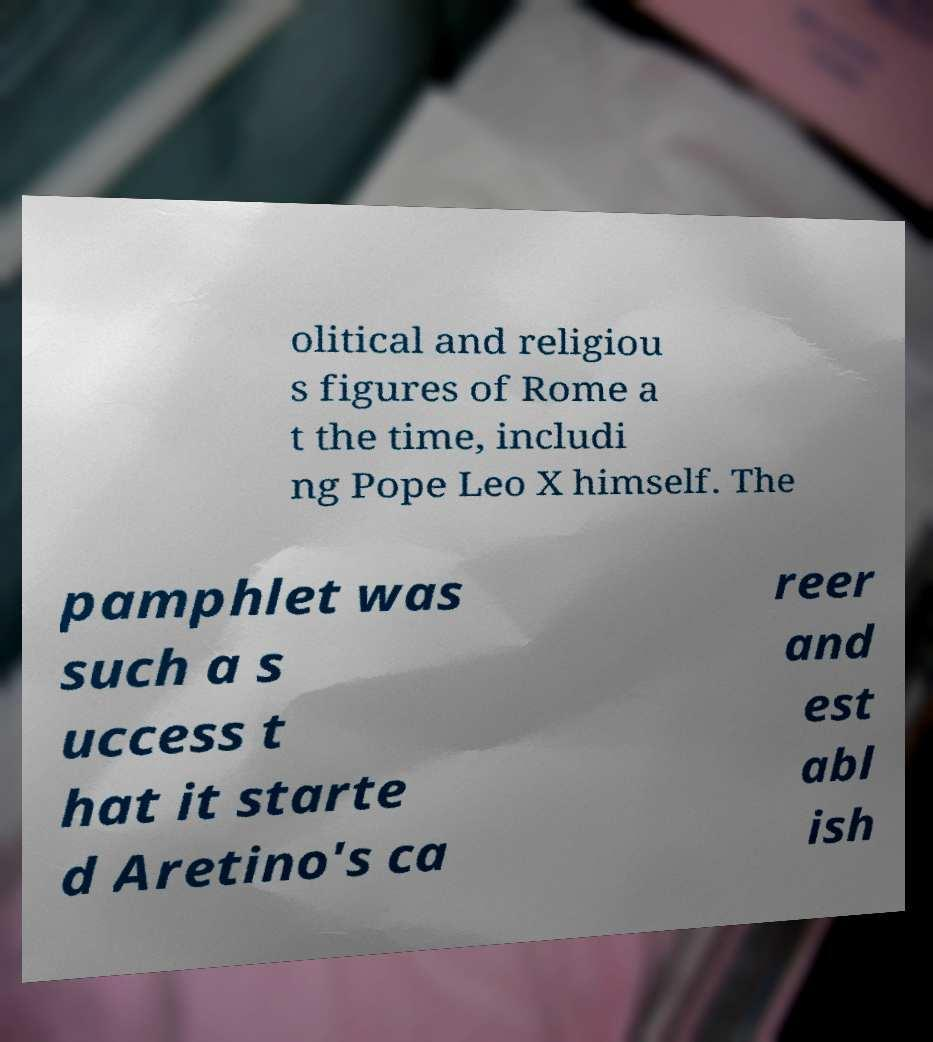For documentation purposes, I need the text within this image transcribed. Could you provide that? olitical and religiou s figures of Rome a t the time, includi ng Pope Leo X himself. The pamphlet was such a s uccess t hat it starte d Aretino's ca reer and est abl ish 